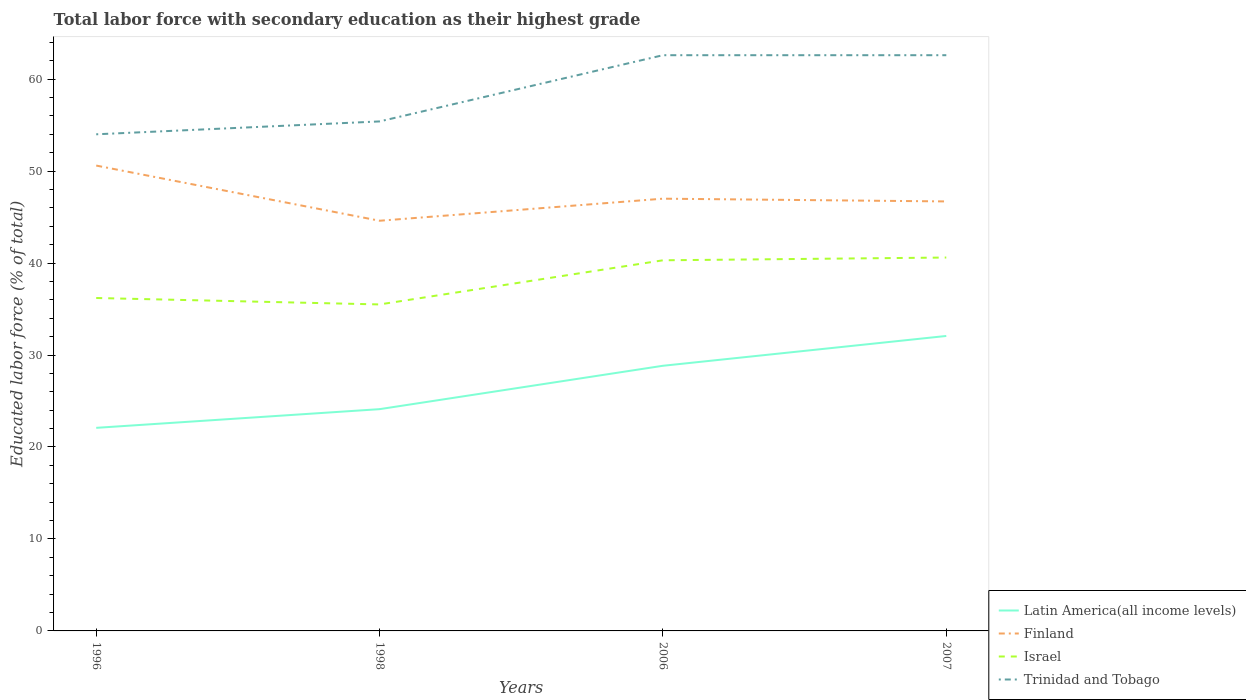How many different coloured lines are there?
Make the answer very short. 4. Does the line corresponding to Latin America(all income levels) intersect with the line corresponding to Trinidad and Tobago?
Offer a terse response. No. Across all years, what is the maximum percentage of total labor force with primary education in Latin America(all income levels)?
Give a very brief answer. 22.08. In which year was the percentage of total labor force with primary education in Israel maximum?
Offer a very short reply. 1998. What is the total percentage of total labor force with primary education in Israel in the graph?
Keep it short and to the point. -4.8. What is the difference between the highest and the second highest percentage of total labor force with primary education in Israel?
Offer a terse response. 5.1. What is the difference between the highest and the lowest percentage of total labor force with primary education in Finland?
Keep it short and to the point. 1. Is the percentage of total labor force with primary education in Latin America(all income levels) strictly greater than the percentage of total labor force with primary education in Trinidad and Tobago over the years?
Your answer should be very brief. Yes. How many lines are there?
Ensure brevity in your answer.  4. How many years are there in the graph?
Keep it short and to the point. 4. How are the legend labels stacked?
Your answer should be compact. Vertical. What is the title of the graph?
Provide a succinct answer. Total labor force with secondary education as their highest grade. What is the label or title of the Y-axis?
Provide a succinct answer. Educated labor force (% of total). What is the Educated labor force (% of total) in Latin America(all income levels) in 1996?
Give a very brief answer. 22.08. What is the Educated labor force (% of total) in Finland in 1996?
Provide a succinct answer. 50.6. What is the Educated labor force (% of total) of Israel in 1996?
Make the answer very short. 36.2. What is the Educated labor force (% of total) of Latin America(all income levels) in 1998?
Make the answer very short. 24.11. What is the Educated labor force (% of total) in Finland in 1998?
Offer a very short reply. 44.6. What is the Educated labor force (% of total) of Israel in 1998?
Offer a terse response. 35.5. What is the Educated labor force (% of total) of Trinidad and Tobago in 1998?
Offer a very short reply. 55.4. What is the Educated labor force (% of total) of Latin America(all income levels) in 2006?
Offer a very short reply. 28.83. What is the Educated labor force (% of total) of Finland in 2006?
Ensure brevity in your answer.  47. What is the Educated labor force (% of total) in Israel in 2006?
Your answer should be very brief. 40.3. What is the Educated labor force (% of total) of Trinidad and Tobago in 2006?
Make the answer very short. 62.6. What is the Educated labor force (% of total) in Latin America(all income levels) in 2007?
Your answer should be compact. 32.07. What is the Educated labor force (% of total) in Finland in 2007?
Your response must be concise. 46.7. What is the Educated labor force (% of total) of Israel in 2007?
Offer a very short reply. 40.6. What is the Educated labor force (% of total) of Trinidad and Tobago in 2007?
Your response must be concise. 62.6. Across all years, what is the maximum Educated labor force (% of total) of Latin America(all income levels)?
Your response must be concise. 32.07. Across all years, what is the maximum Educated labor force (% of total) in Finland?
Make the answer very short. 50.6. Across all years, what is the maximum Educated labor force (% of total) in Israel?
Your response must be concise. 40.6. Across all years, what is the maximum Educated labor force (% of total) of Trinidad and Tobago?
Your response must be concise. 62.6. Across all years, what is the minimum Educated labor force (% of total) in Latin America(all income levels)?
Make the answer very short. 22.08. Across all years, what is the minimum Educated labor force (% of total) in Finland?
Give a very brief answer. 44.6. Across all years, what is the minimum Educated labor force (% of total) in Israel?
Ensure brevity in your answer.  35.5. Across all years, what is the minimum Educated labor force (% of total) of Trinidad and Tobago?
Your answer should be very brief. 54. What is the total Educated labor force (% of total) in Latin America(all income levels) in the graph?
Keep it short and to the point. 107.1. What is the total Educated labor force (% of total) in Finland in the graph?
Keep it short and to the point. 188.9. What is the total Educated labor force (% of total) of Israel in the graph?
Your answer should be compact. 152.6. What is the total Educated labor force (% of total) in Trinidad and Tobago in the graph?
Your answer should be very brief. 234.6. What is the difference between the Educated labor force (% of total) of Latin America(all income levels) in 1996 and that in 1998?
Provide a short and direct response. -2.03. What is the difference between the Educated labor force (% of total) in Finland in 1996 and that in 1998?
Offer a very short reply. 6. What is the difference between the Educated labor force (% of total) of Trinidad and Tobago in 1996 and that in 1998?
Offer a terse response. -1.4. What is the difference between the Educated labor force (% of total) in Latin America(all income levels) in 1996 and that in 2006?
Provide a short and direct response. -6.75. What is the difference between the Educated labor force (% of total) of Trinidad and Tobago in 1996 and that in 2006?
Keep it short and to the point. -8.6. What is the difference between the Educated labor force (% of total) of Latin America(all income levels) in 1996 and that in 2007?
Offer a very short reply. -9.99. What is the difference between the Educated labor force (% of total) of Finland in 1996 and that in 2007?
Provide a short and direct response. 3.9. What is the difference between the Educated labor force (% of total) of Israel in 1996 and that in 2007?
Your answer should be very brief. -4.4. What is the difference between the Educated labor force (% of total) of Latin America(all income levels) in 1998 and that in 2006?
Make the answer very short. -4.72. What is the difference between the Educated labor force (% of total) of Trinidad and Tobago in 1998 and that in 2006?
Give a very brief answer. -7.2. What is the difference between the Educated labor force (% of total) of Latin America(all income levels) in 1998 and that in 2007?
Ensure brevity in your answer.  -7.96. What is the difference between the Educated labor force (% of total) of Trinidad and Tobago in 1998 and that in 2007?
Make the answer very short. -7.2. What is the difference between the Educated labor force (% of total) of Latin America(all income levels) in 2006 and that in 2007?
Your answer should be compact. -3.24. What is the difference between the Educated labor force (% of total) of Finland in 2006 and that in 2007?
Your response must be concise. 0.3. What is the difference between the Educated labor force (% of total) in Israel in 2006 and that in 2007?
Make the answer very short. -0.3. What is the difference between the Educated labor force (% of total) of Trinidad and Tobago in 2006 and that in 2007?
Make the answer very short. 0. What is the difference between the Educated labor force (% of total) in Latin America(all income levels) in 1996 and the Educated labor force (% of total) in Finland in 1998?
Offer a very short reply. -22.52. What is the difference between the Educated labor force (% of total) in Latin America(all income levels) in 1996 and the Educated labor force (% of total) in Israel in 1998?
Your response must be concise. -13.42. What is the difference between the Educated labor force (% of total) in Latin America(all income levels) in 1996 and the Educated labor force (% of total) in Trinidad and Tobago in 1998?
Your answer should be compact. -33.32. What is the difference between the Educated labor force (% of total) of Finland in 1996 and the Educated labor force (% of total) of Israel in 1998?
Offer a very short reply. 15.1. What is the difference between the Educated labor force (% of total) of Finland in 1996 and the Educated labor force (% of total) of Trinidad and Tobago in 1998?
Ensure brevity in your answer.  -4.8. What is the difference between the Educated labor force (% of total) in Israel in 1996 and the Educated labor force (% of total) in Trinidad and Tobago in 1998?
Your response must be concise. -19.2. What is the difference between the Educated labor force (% of total) of Latin America(all income levels) in 1996 and the Educated labor force (% of total) of Finland in 2006?
Offer a terse response. -24.92. What is the difference between the Educated labor force (% of total) of Latin America(all income levels) in 1996 and the Educated labor force (% of total) of Israel in 2006?
Your answer should be very brief. -18.22. What is the difference between the Educated labor force (% of total) of Latin America(all income levels) in 1996 and the Educated labor force (% of total) of Trinidad and Tobago in 2006?
Ensure brevity in your answer.  -40.52. What is the difference between the Educated labor force (% of total) in Israel in 1996 and the Educated labor force (% of total) in Trinidad and Tobago in 2006?
Your response must be concise. -26.4. What is the difference between the Educated labor force (% of total) in Latin America(all income levels) in 1996 and the Educated labor force (% of total) in Finland in 2007?
Your answer should be very brief. -24.62. What is the difference between the Educated labor force (% of total) in Latin America(all income levels) in 1996 and the Educated labor force (% of total) in Israel in 2007?
Your response must be concise. -18.52. What is the difference between the Educated labor force (% of total) of Latin America(all income levels) in 1996 and the Educated labor force (% of total) of Trinidad and Tobago in 2007?
Your answer should be very brief. -40.52. What is the difference between the Educated labor force (% of total) of Finland in 1996 and the Educated labor force (% of total) of Israel in 2007?
Keep it short and to the point. 10. What is the difference between the Educated labor force (% of total) in Finland in 1996 and the Educated labor force (% of total) in Trinidad and Tobago in 2007?
Offer a very short reply. -12. What is the difference between the Educated labor force (% of total) of Israel in 1996 and the Educated labor force (% of total) of Trinidad and Tobago in 2007?
Give a very brief answer. -26.4. What is the difference between the Educated labor force (% of total) in Latin America(all income levels) in 1998 and the Educated labor force (% of total) in Finland in 2006?
Your answer should be compact. -22.89. What is the difference between the Educated labor force (% of total) of Latin America(all income levels) in 1998 and the Educated labor force (% of total) of Israel in 2006?
Provide a short and direct response. -16.19. What is the difference between the Educated labor force (% of total) of Latin America(all income levels) in 1998 and the Educated labor force (% of total) of Trinidad and Tobago in 2006?
Your response must be concise. -38.49. What is the difference between the Educated labor force (% of total) in Finland in 1998 and the Educated labor force (% of total) in Israel in 2006?
Your answer should be compact. 4.3. What is the difference between the Educated labor force (% of total) of Israel in 1998 and the Educated labor force (% of total) of Trinidad and Tobago in 2006?
Offer a terse response. -27.1. What is the difference between the Educated labor force (% of total) in Latin America(all income levels) in 1998 and the Educated labor force (% of total) in Finland in 2007?
Offer a very short reply. -22.59. What is the difference between the Educated labor force (% of total) of Latin America(all income levels) in 1998 and the Educated labor force (% of total) of Israel in 2007?
Make the answer very short. -16.49. What is the difference between the Educated labor force (% of total) in Latin America(all income levels) in 1998 and the Educated labor force (% of total) in Trinidad and Tobago in 2007?
Ensure brevity in your answer.  -38.49. What is the difference between the Educated labor force (% of total) of Finland in 1998 and the Educated labor force (% of total) of Israel in 2007?
Keep it short and to the point. 4. What is the difference between the Educated labor force (% of total) in Israel in 1998 and the Educated labor force (% of total) in Trinidad and Tobago in 2007?
Your answer should be compact. -27.1. What is the difference between the Educated labor force (% of total) of Latin America(all income levels) in 2006 and the Educated labor force (% of total) of Finland in 2007?
Offer a terse response. -17.87. What is the difference between the Educated labor force (% of total) in Latin America(all income levels) in 2006 and the Educated labor force (% of total) in Israel in 2007?
Your response must be concise. -11.77. What is the difference between the Educated labor force (% of total) in Latin America(all income levels) in 2006 and the Educated labor force (% of total) in Trinidad and Tobago in 2007?
Provide a short and direct response. -33.77. What is the difference between the Educated labor force (% of total) in Finland in 2006 and the Educated labor force (% of total) in Israel in 2007?
Offer a terse response. 6.4. What is the difference between the Educated labor force (% of total) of Finland in 2006 and the Educated labor force (% of total) of Trinidad and Tobago in 2007?
Give a very brief answer. -15.6. What is the difference between the Educated labor force (% of total) in Israel in 2006 and the Educated labor force (% of total) in Trinidad and Tobago in 2007?
Offer a terse response. -22.3. What is the average Educated labor force (% of total) in Latin America(all income levels) per year?
Offer a very short reply. 26.77. What is the average Educated labor force (% of total) of Finland per year?
Offer a very short reply. 47.23. What is the average Educated labor force (% of total) of Israel per year?
Provide a short and direct response. 38.15. What is the average Educated labor force (% of total) of Trinidad and Tobago per year?
Provide a short and direct response. 58.65. In the year 1996, what is the difference between the Educated labor force (% of total) of Latin America(all income levels) and Educated labor force (% of total) of Finland?
Offer a very short reply. -28.52. In the year 1996, what is the difference between the Educated labor force (% of total) in Latin America(all income levels) and Educated labor force (% of total) in Israel?
Provide a succinct answer. -14.12. In the year 1996, what is the difference between the Educated labor force (% of total) of Latin America(all income levels) and Educated labor force (% of total) of Trinidad and Tobago?
Make the answer very short. -31.92. In the year 1996, what is the difference between the Educated labor force (% of total) of Israel and Educated labor force (% of total) of Trinidad and Tobago?
Offer a terse response. -17.8. In the year 1998, what is the difference between the Educated labor force (% of total) in Latin America(all income levels) and Educated labor force (% of total) in Finland?
Your answer should be very brief. -20.49. In the year 1998, what is the difference between the Educated labor force (% of total) in Latin America(all income levels) and Educated labor force (% of total) in Israel?
Keep it short and to the point. -11.39. In the year 1998, what is the difference between the Educated labor force (% of total) in Latin America(all income levels) and Educated labor force (% of total) in Trinidad and Tobago?
Give a very brief answer. -31.29. In the year 1998, what is the difference between the Educated labor force (% of total) in Finland and Educated labor force (% of total) in Trinidad and Tobago?
Your response must be concise. -10.8. In the year 1998, what is the difference between the Educated labor force (% of total) of Israel and Educated labor force (% of total) of Trinidad and Tobago?
Your response must be concise. -19.9. In the year 2006, what is the difference between the Educated labor force (% of total) in Latin America(all income levels) and Educated labor force (% of total) in Finland?
Your answer should be very brief. -18.17. In the year 2006, what is the difference between the Educated labor force (% of total) of Latin America(all income levels) and Educated labor force (% of total) of Israel?
Your response must be concise. -11.47. In the year 2006, what is the difference between the Educated labor force (% of total) of Latin America(all income levels) and Educated labor force (% of total) of Trinidad and Tobago?
Ensure brevity in your answer.  -33.77. In the year 2006, what is the difference between the Educated labor force (% of total) in Finland and Educated labor force (% of total) in Israel?
Your response must be concise. 6.7. In the year 2006, what is the difference between the Educated labor force (% of total) of Finland and Educated labor force (% of total) of Trinidad and Tobago?
Provide a short and direct response. -15.6. In the year 2006, what is the difference between the Educated labor force (% of total) of Israel and Educated labor force (% of total) of Trinidad and Tobago?
Ensure brevity in your answer.  -22.3. In the year 2007, what is the difference between the Educated labor force (% of total) of Latin America(all income levels) and Educated labor force (% of total) of Finland?
Keep it short and to the point. -14.63. In the year 2007, what is the difference between the Educated labor force (% of total) of Latin America(all income levels) and Educated labor force (% of total) of Israel?
Make the answer very short. -8.53. In the year 2007, what is the difference between the Educated labor force (% of total) of Latin America(all income levels) and Educated labor force (% of total) of Trinidad and Tobago?
Keep it short and to the point. -30.53. In the year 2007, what is the difference between the Educated labor force (% of total) of Finland and Educated labor force (% of total) of Trinidad and Tobago?
Offer a terse response. -15.9. What is the ratio of the Educated labor force (% of total) in Latin America(all income levels) in 1996 to that in 1998?
Offer a very short reply. 0.92. What is the ratio of the Educated labor force (% of total) in Finland in 1996 to that in 1998?
Offer a terse response. 1.13. What is the ratio of the Educated labor force (% of total) of Israel in 1996 to that in 1998?
Offer a terse response. 1.02. What is the ratio of the Educated labor force (% of total) in Trinidad and Tobago in 1996 to that in 1998?
Give a very brief answer. 0.97. What is the ratio of the Educated labor force (% of total) of Latin America(all income levels) in 1996 to that in 2006?
Give a very brief answer. 0.77. What is the ratio of the Educated labor force (% of total) of Finland in 1996 to that in 2006?
Offer a terse response. 1.08. What is the ratio of the Educated labor force (% of total) of Israel in 1996 to that in 2006?
Your answer should be very brief. 0.9. What is the ratio of the Educated labor force (% of total) in Trinidad and Tobago in 1996 to that in 2006?
Offer a very short reply. 0.86. What is the ratio of the Educated labor force (% of total) of Latin America(all income levels) in 1996 to that in 2007?
Your answer should be very brief. 0.69. What is the ratio of the Educated labor force (% of total) in Finland in 1996 to that in 2007?
Ensure brevity in your answer.  1.08. What is the ratio of the Educated labor force (% of total) of Israel in 1996 to that in 2007?
Give a very brief answer. 0.89. What is the ratio of the Educated labor force (% of total) in Trinidad and Tobago in 1996 to that in 2007?
Offer a very short reply. 0.86. What is the ratio of the Educated labor force (% of total) of Latin America(all income levels) in 1998 to that in 2006?
Provide a succinct answer. 0.84. What is the ratio of the Educated labor force (% of total) of Finland in 1998 to that in 2006?
Provide a short and direct response. 0.95. What is the ratio of the Educated labor force (% of total) in Israel in 1998 to that in 2006?
Make the answer very short. 0.88. What is the ratio of the Educated labor force (% of total) of Trinidad and Tobago in 1998 to that in 2006?
Your answer should be very brief. 0.89. What is the ratio of the Educated labor force (% of total) in Latin America(all income levels) in 1998 to that in 2007?
Offer a terse response. 0.75. What is the ratio of the Educated labor force (% of total) of Finland in 1998 to that in 2007?
Ensure brevity in your answer.  0.95. What is the ratio of the Educated labor force (% of total) in Israel in 1998 to that in 2007?
Your answer should be very brief. 0.87. What is the ratio of the Educated labor force (% of total) in Trinidad and Tobago in 1998 to that in 2007?
Your answer should be compact. 0.89. What is the ratio of the Educated labor force (% of total) of Latin America(all income levels) in 2006 to that in 2007?
Ensure brevity in your answer.  0.9. What is the ratio of the Educated labor force (% of total) of Finland in 2006 to that in 2007?
Ensure brevity in your answer.  1.01. What is the ratio of the Educated labor force (% of total) of Trinidad and Tobago in 2006 to that in 2007?
Make the answer very short. 1. What is the difference between the highest and the second highest Educated labor force (% of total) in Latin America(all income levels)?
Your response must be concise. 3.24. What is the difference between the highest and the second highest Educated labor force (% of total) of Finland?
Provide a short and direct response. 3.6. What is the difference between the highest and the lowest Educated labor force (% of total) in Latin America(all income levels)?
Ensure brevity in your answer.  9.99. What is the difference between the highest and the lowest Educated labor force (% of total) in Finland?
Make the answer very short. 6. What is the difference between the highest and the lowest Educated labor force (% of total) of Trinidad and Tobago?
Give a very brief answer. 8.6. 